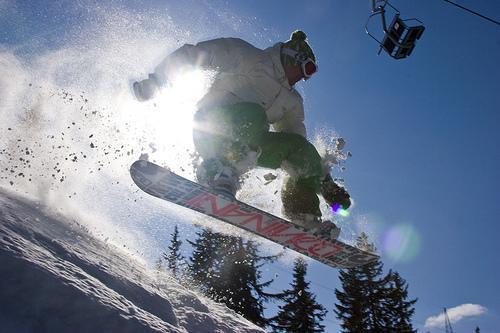How many people in the picture?
Give a very brief answer. 1. 